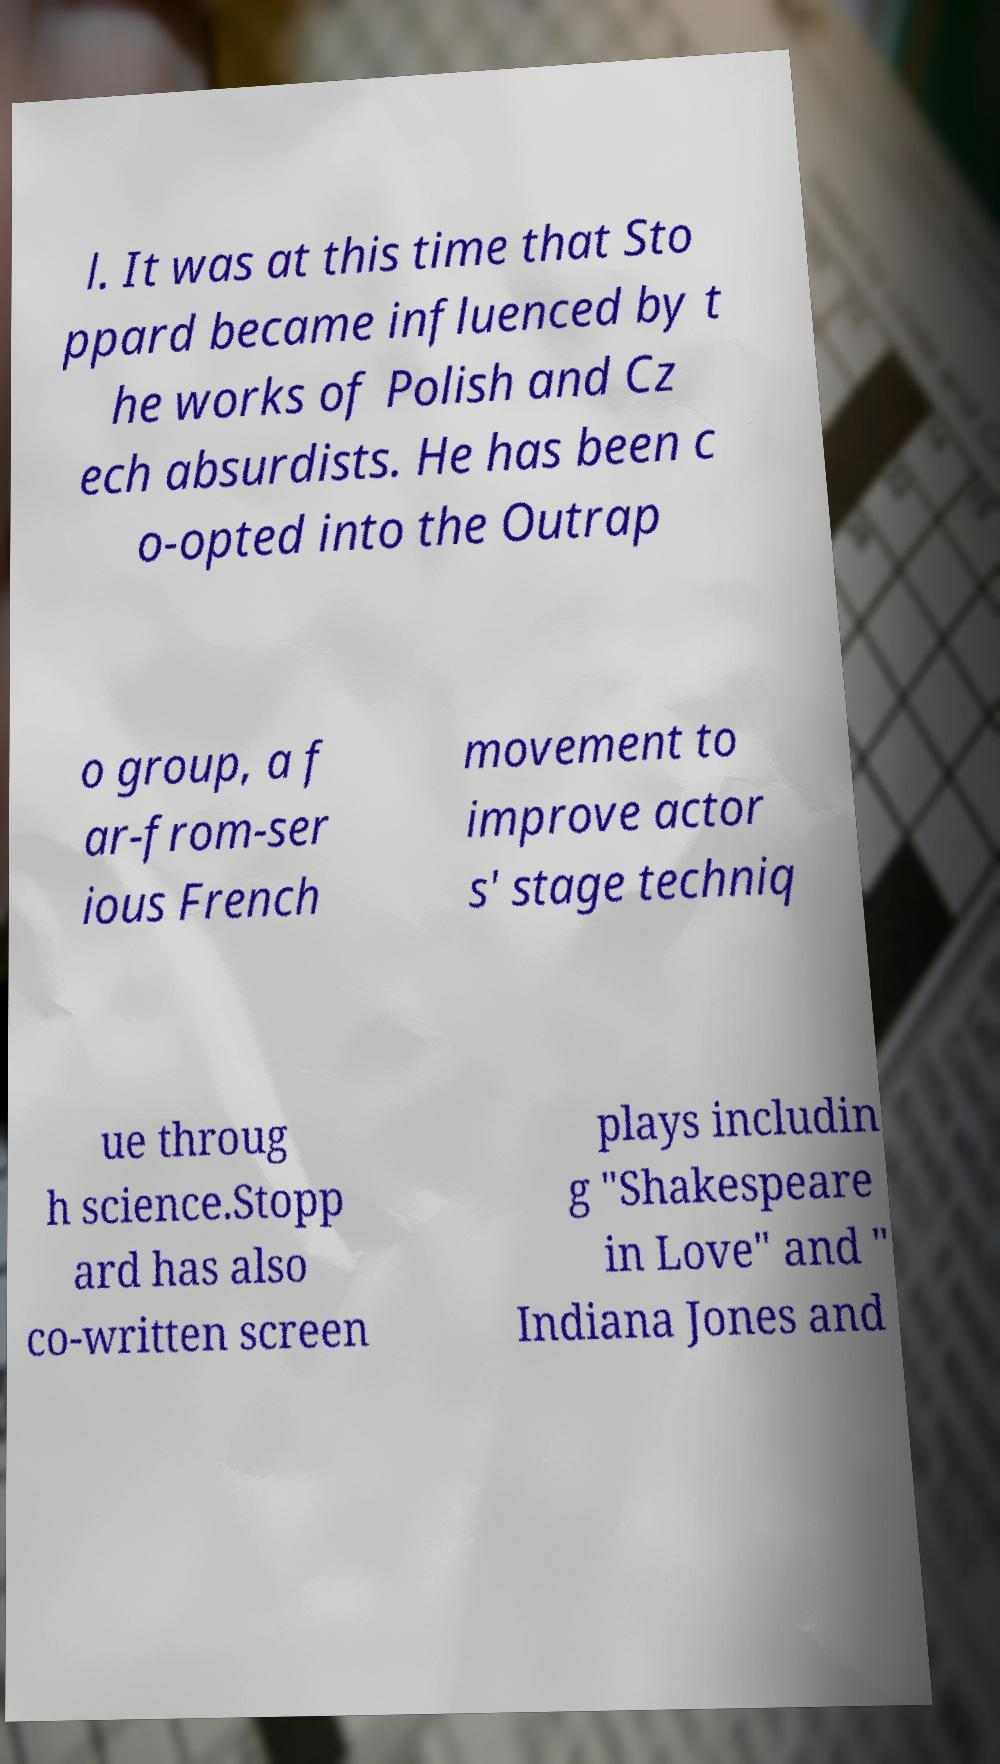Could you extract and type out the text from this image? l. It was at this time that Sto ppard became influenced by t he works of Polish and Cz ech absurdists. He has been c o-opted into the Outrap o group, a f ar-from-ser ious French movement to improve actor s' stage techniq ue throug h science.Stopp ard has also co-written screen plays includin g "Shakespeare in Love" and " Indiana Jones and 